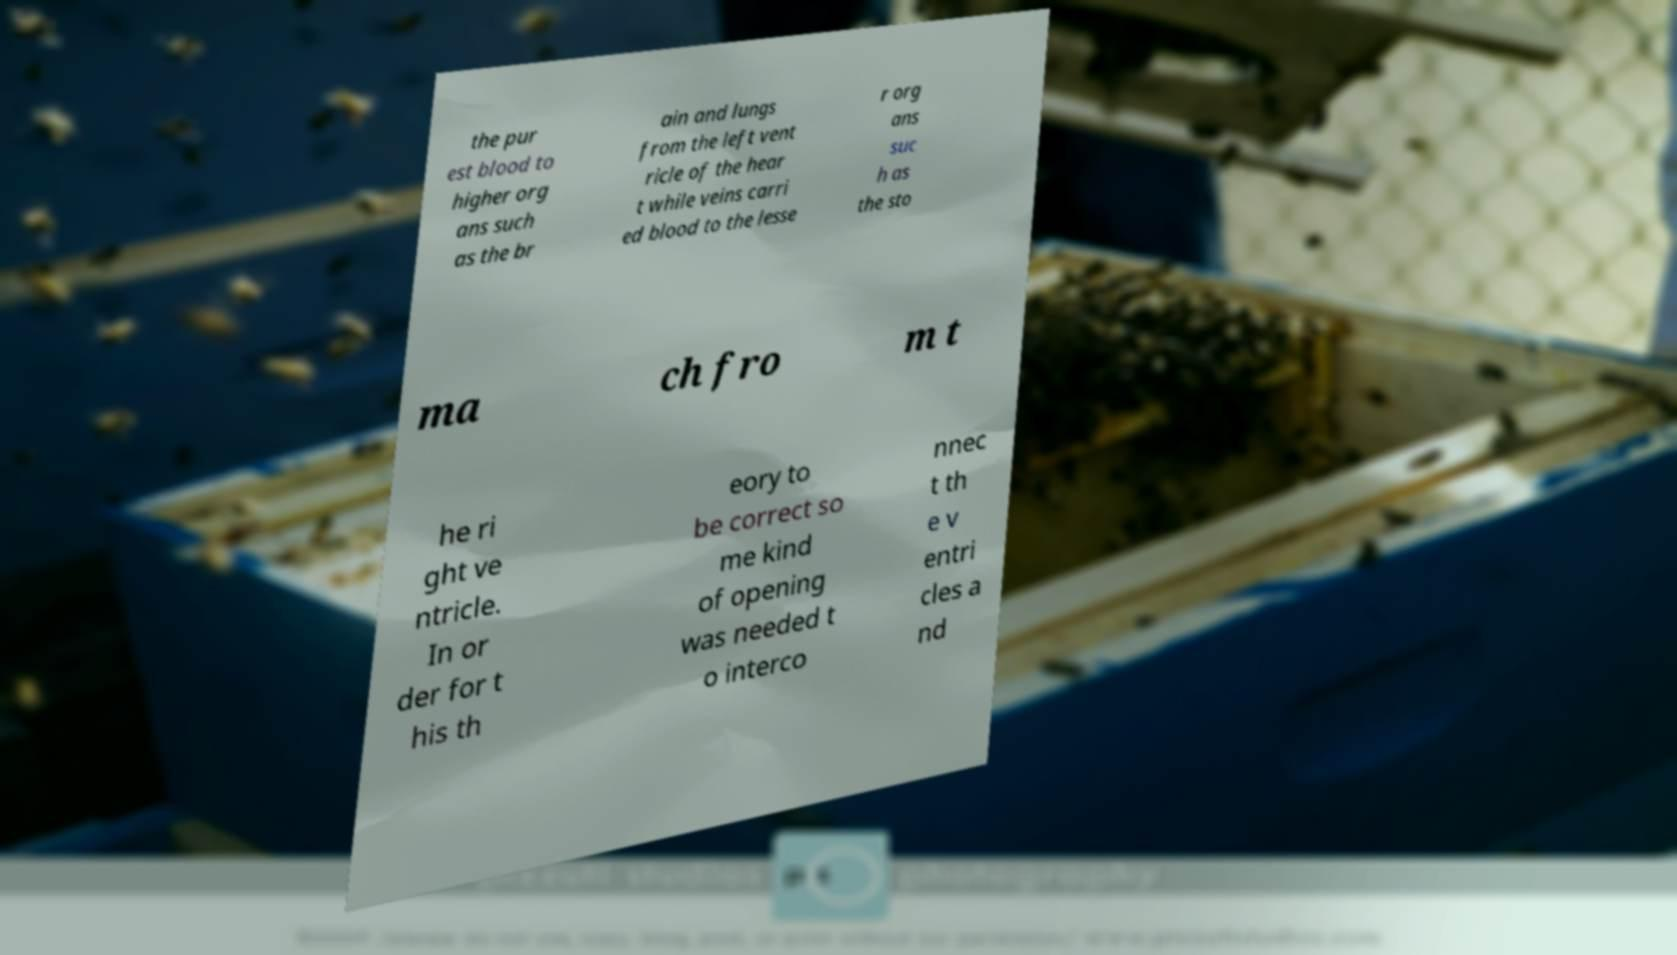Could you extract and type out the text from this image? the pur est blood to higher org ans such as the br ain and lungs from the left vent ricle of the hear t while veins carri ed blood to the lesse r org ans suc h as the sto ma ch fro m t he ri ght ve ntricle. In or der for t his th eory to be correct so me kind of opening was needed t o interco nnec t th e v entri cles a nd 